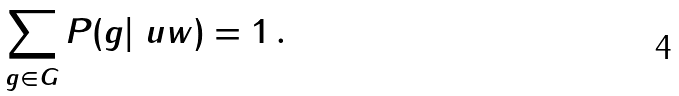Convert formula to latex. <formula><loc_0><loc_0><loc_500><loc_500>\sum _ { g \in G } P ( g | \ u w ) = 1 \, .</formula> 